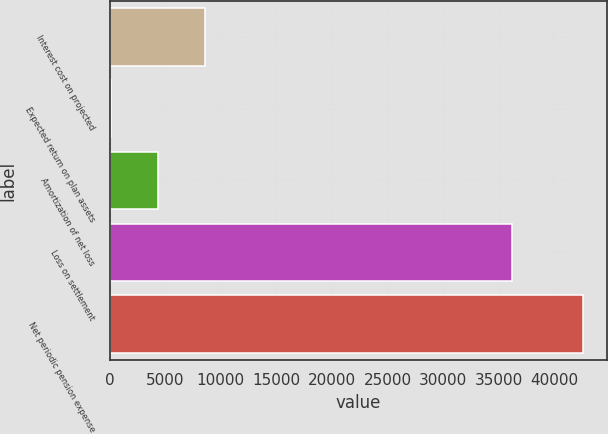<chart> <loc_0><loc_0><loc_500><loc_500><bar_chart><fcel>Interest cost on projected<fcel>Expected return on plan assets<fcel>Amortization of net loss<fcel>Loss on settlement<fcel>Net periodic pension expense<nl><fcel>8591<fcel>92<fcel>4341.5<fcel>36203<fcel>42587<nl></chart> 